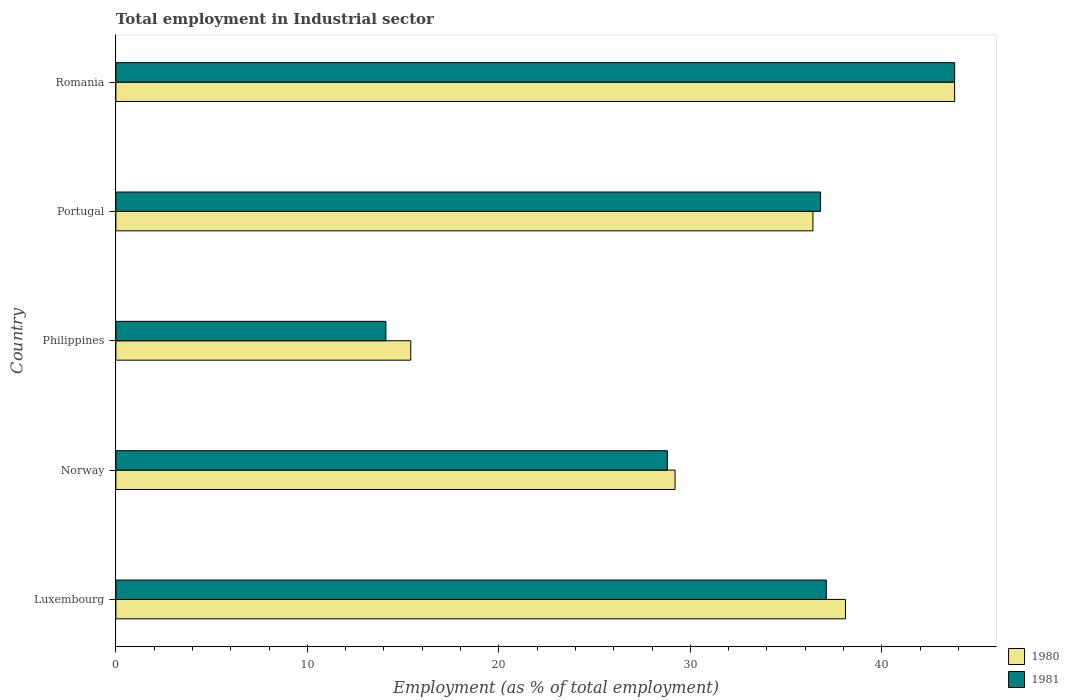How many different coloured bars are there?
Make the answer very short. 2. Are the number of bars per tick equal to the number of legend labels?
Offer a terse response. Yes. How many bars are there on the 1st tick from the top?
Give a very brief answer. 2. How many bars are there on the 5th tick from the bottom?
Ensure brevity in your answer.  2. What is the label of the 4th group of bars from the top?
Offer a very short reply. Norway. What is the employment in industrial sector in 1981 in Romania?
Your answer should be compact. 43.8. Across all countries, what is the maximum employment in industrial sector in 1980?
Your answer should be compact. 43.8. Across all countries, what is the minimum employment in industrial sector in 1981?
Your answer should be compact. 14.1. In which country was the employment in industrial sector in 1981 maximum?
Offer a very short reply. Romania. In which country was the employment in industrial sector in 1980 minimum?
Give a very brief answer. Philippines. What is the total employment in industrial sector in 1981 in the graph?
Offer a very short reply. 160.6. What is the difference between the employment in industrial sector in 1981 in Philippines and that in Portugal?
Your answer should be compact. -22.7. What is the difference between the employment in industrial sector in 1980 in Portugal and the employment in industrial sector in 1981 in Romania?
Your response must be concise. -7.4. What is the average employment in industrial sector in 1980 per country?
Offer a very short reply. 32.58. What is the difference between the employment in industrial sector in 1981 and employment in industrial sector in 1980 in Luxembourg?
Provide a short and direct response. -1. In how many countries, is the employment in industrial sector in 1980 greater than 36 %?
Give a very brief answer. 3. What is the ratio of the employment in industrial sector in 1980 in Portugal to that in Romania?
Your answer should be very brief. 0.83. Is the employment in industrial sector in 1980 in Portugal less than that in Romania?
Make the answer very short. Yes. What is the difference between the highest and the second highest employment in industrial sector in 1981?
Your answer should be compact. 6.7. What is the difference between the highest and the lowest employment in industrial sector in 1981?
Give a very brief answer. 29.7. In how many countries, is the employment in industrial sector in 1981 greater than the average employment in industrial sector in 1981 taken over all countries?
Offer a very short reply. 3. What does the 2nd bar from the top in Norway represents?
Provide a short and direct response. 1980. How many bars are there?
Provide a short and direct response. 10. Are all the bars in the graph horizontal?
Give a very brief answer. Yes. How many countries are there in the graph?
Keep it short and to the point. 5. Does the graph contain any zero values?
Provide a succinct answer. No. How many legend labels are there?
Your answer should be compact. 2. How are the legend labels stacked?
Make the answer very short. Vertical. What is the title of the graph?
Provide a short and direct response. Total employment in Industrial sector. Does "1981" appear as one of the legend labels in the graph?
Give a very brief answer. Yes. What is the label or title of the X-axis?
Your answer should be compact. Employment (as % of total employment). What is the Employment (as % of total employment) in 1980 in Luxembourg?
Give a very brief answer. 38.1. What is the Employment (as % of total employment) in 1981 in Luxembourg?
Your answer should be compact. 37.1. What is the Employment (as % of total employment) in 1980 in Norway?
Give a very brief answer. 29.2. What is the Employment (as % of total employment) of 1981 in Norway?
Give a very brief answer. 28.8. What is the Employment (as % of total employment) of 1980 in Philippines?
Keep it short and to the point. 15.4. What is the Employment (as % of total employment) of 1981 in Philippines?
Offer a terse response. 14.1. What is the Employment (as % of total employment) in 1980 in Portugal?
Offer a very short reply. 36.4. What is the Employment (as % of total employment) in 1981 in Portugal?
Your answer should be very brief. 36.8. What is the Employment (as % of total employment) in 1980 in Romania?
Your answer should be very brief. 43.8. What is the Employment (as % of total employment) in 1981 in Romania?
Offer a very short reply. 43.8. Across all countries, what is the maximum Employment (as % of total employment) in 1980?
Provide a succinct answer. 43.8. Across all countries, what is the maximum Employment (as % of total employment) in 1981?
Give a very brief answer. 43.8. Across all countries, what is the minimum Employment (as % of total employment) of 1980?
Offer a terse response. 15.4. Across all countries, what is the minimum Employment (as % of total employment) in 1981?
Your answer should be very brief. 14.1. What is the total Employment (as % of total employment) of 1980 in the graph?
Provide a short and direct response. 162.9. What is the total Employment (as % of total employment) of 1981 in the graph?
Offer a terse response. 160.6. What is the difference between the Employment (as % of total employment) in 1980 in Luxembourg and that in Philippines?
Keep it short and to the point. 22.7. What is the difference between the Employment (as % of total employment) in 1980 in Norway and that in Philippines?
Your response must be concise. 13.8. What is the difference between the Employment (as % of total employment) in 1980 in Norway and that in Portugal?
Your response must be concise. -7.2. What is the difference between the Employment (as % of total employment) in 1980 in Norway and that in Romania?
Your answer should be very brief. -14.6. What is the difference between the Employment (as % of total employment) of 1981 in Norway and that in Romania?
Provide a short and direct response. -15. What is the difference between the Employment (as % of total employment) of 1981 in Philippines and that in Portugal?
Provide a succinct answer. -22.7. What is the difference between the Employment (as % of total employment) in 1980 in Philippines and that in Romania?
Make the answer very short. -28.4. What is the difference between the Employment (as % of total employment) in 1981 in Philippines and that in Romania?
Your answer should be very brief. -29.7. What is the difference between the Employment (as % of total employment) of 1980 in Luxembourg and the Employment (as % of total employment) of 1981 in Portugal?
Ensure brevity in your answer.  1.3. What is the difference between the Employment (as % of total employment) of 1980 in Luxembourg and the Employment (as % of total employment) of 1981 in Romania?
Your answer should be compact. -5.7. What is the difference between the Employment (as % of total employment) in 1980 in Norway and the Employment (as % of total employment) in 1981 in Romania?
Your answer should be very brief. -14.6. What is the difference between the Employment (as % of total employment) of 1980 in Philippines and the Employment (as % of total employment) of 1981 in Portugal?
Your answer should be compact. -21.4. What is the difference between the Employment (as % of total employment) of 1980 in Philippines and the Employment (as % of total employment) of 1981 in Romania?
Give a very brief answer. -28.4. What is the difference between the Employment (as % of total employment) in 1980 in Portugal and the Employment (as % of total employment) in 1981 in Romania?
Offer a terse response. -7.4. What is the average Employment (as % of total employment) of 1980 per country?
Keep it short and to the point. 32.58. What is the average Employment (as % of total employment) in 1981 per country?
Keep it short and to the point. 32.12. What is the difference between the Employment (as % of total employment) of 1980 and Employment (as % of total employment) of 1981 in Luxembourg?
Make the answer very short. 1. What is the difference between the Employment (as % of total employment) in 1980 and Employment (as % of total employment) in 1981 in Norway?
Make the answer very short. 0.4. What is the difference between the Employment (as % of total employment) in 1980 and Employment (as % of total employment) in 1981 in Philippines?
Make the answer very short. 1.3. What is the difference between the Employment (as % of total employment) in 1980 and Employment (as % of total employment) in 1981 in Portugal?
Keep it short and to the point. -0.4. What is the difference between the Employment (as % of total employment) of 1980 and Employment (as % of total employment) of 1981 in Romania?
Provide a short and direct response. 0. What is the ratio of the Employment (as % of total employment) of 1980 in Luxembourg to that in Norway?
Your response must be concise. 1.3. What is the ratio of the Employment (as % of total employment) in 1981 in Luxembourg to that in Norway?
Your answer should be compact. 1.29. What is the ratio of the Employment (as % of total employment) in 1980 in Luxembourg to that in Philippines?
Offer a terse response. 2.47. What is the ratio of the Employment (as % of total employment) in 1981 in Luxembourg to that in Philippines?
Your response must be concise. 2.63. What is the ratio of the Employment (as % of total employment) of 1980 in Luxembourg to that in Portugal?
Ensure brevity in your answer.  1.05. What is the ratio of the Employment (as % of total employment) in 1981 in Luxembourg to that in Portugal?
Your answer should be very brief. 1.01. What is the ratio of the Employment (as % of total employment) of 1980 in Luxembourg to that in Romania?
Make the answer very short. 0.87. What is the ratio of the Employment (as % of total employment) in 1981 in Luxembourg to that in Romania?
Ensure brevity in your answer.  0.85. What is the ratio of the Employment (as % of total employment) of 1980 in Norway to that in Philippines?
Keep it short and to the point. 1.9. What is the ratio of the Employment (as % of total employment) in 1981 in Norway to that in Philippines?
Your response must be concise. 2.04. What is the ratio of the Employment (as % of total employment) of 1980 in Norway to that in Portugal?
Offer a very short reply. 0.8. What is the ratio of the Employment (as % of total employment) of 1981 in Norway to that in Portugal?
Ensure brevity in your answer.  0.78. What is the ratio of the Employment (as % of total employment) of 1981 in Norway to that in Romania?
Your answer should be very brief. 0.66. What is the ratio of the Employment (as % of total employment) of 1980 in Philippines to that in Portugal?
Keep it short and to the point. 0.42. What is the ratio of the Employment (as % of total employment) in 1981 in Philippines to that in Portugal?
Offer a very short reply. 0.38. What is the ratio of the Employment (as % of total employment) of 1980 in Philippines to that in Romania?
Keep it short and to the point. 0.35. What is the ratio of the Employment (as % of total employment) of 1981 in Philippines to that in Romania?
Make the answer very short. 0.32. What is the ratio of the Employment (as % of total employment) of 1980 in Portugal to that in Romania?
Ensure brevity in your answer.  0.83. What is the ratio of the Employment (as % of total employment) in 1981 in Portugal to that in Romania?
Offer a terse response. 0.84. What is the difference between the highest and the second highest Employment (as % of total employment) of 1980?
Your answer should be compact. 5.7. What is the difference between the highest and the second highest Employment (as % of total employment) of 1981?
Give a very brief answer. 6.7. What is the difference between the highest and the lowest Employment (as % of total employment) of 1980?
Offer a very short reply. 28.4. What is the difference between the highest and the lowest Employment (as % of total employment) of 1981?
Provide a short and direct response. 29.7. 